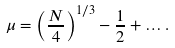<formula> <loc_0><loc_0><loc_500><loc_500>\mu = \left ( \frac { N } { 4 } \right ) ^ { 1 / 3 } - \frac { 1 } { 2 } + \dots .</formula> 